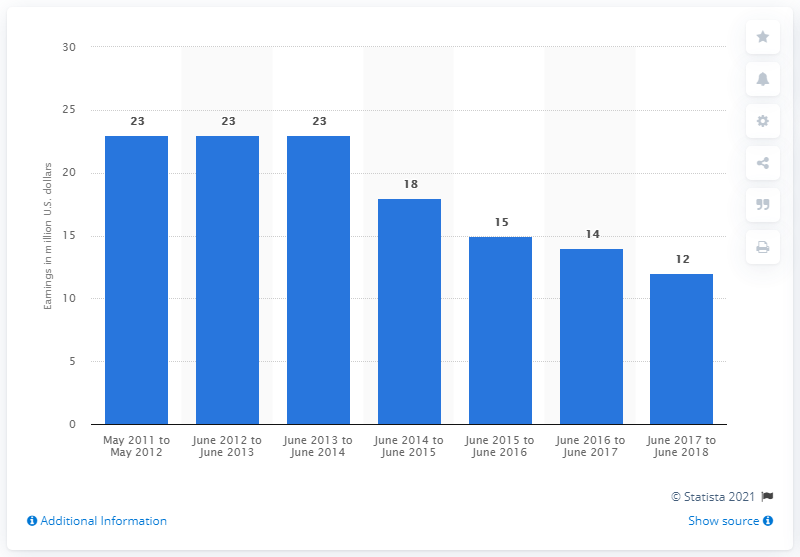Mention a couple of crucial points in this snapshot. Nora Roberts earned a significant amount of money in the previous year. Nora Roberts earned a significant amount of money between June 2017 and June 2018. 